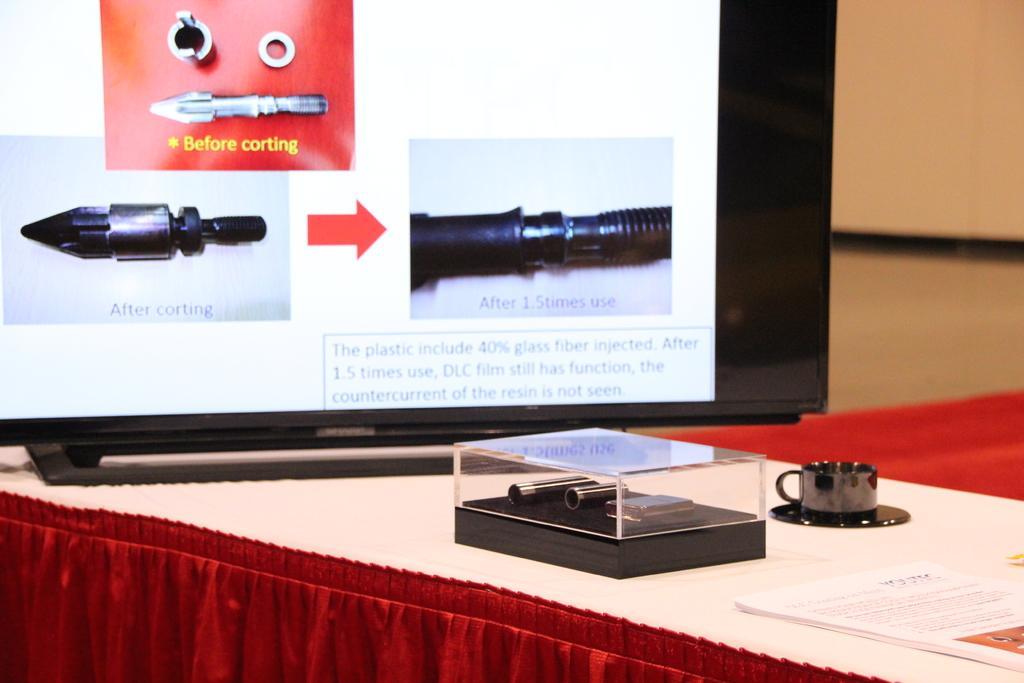Please provide a concise description of this image. In this image there are papers, cup with a saucer , bullets in a glass box and a television with bullets photos on the screen , which are on the table. 